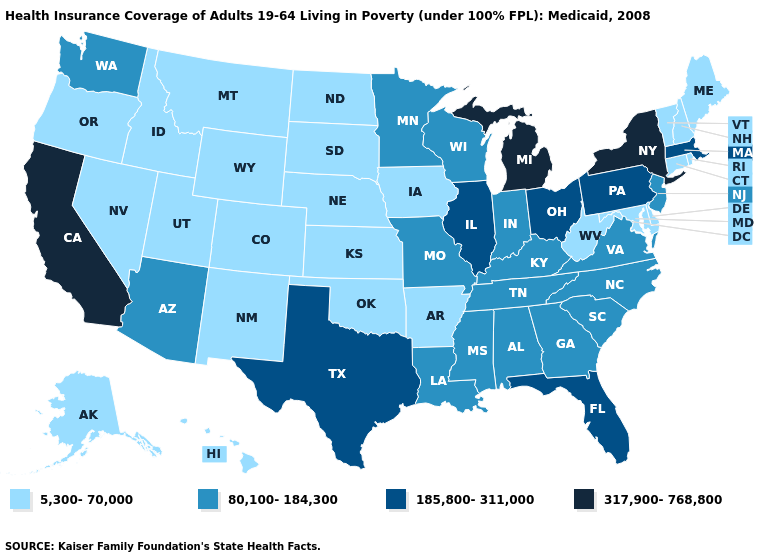Does the first symbol in the legend represent the smallest category?
Give a very brief answer. Yes. What is the highest value in the West ?
Be succinct. 317,900-768,800. What is the value of Kansas?
Quick response, please. 5,300-70,000. What is the highest value in the MidWest ?
Write a very short answer. 317,900-768,800. Among the states that border Connecticut , which have the lowest value?
Short answer required. Rhode Island. What is the value of Pennsylvania?
Short answer required. 185,800-311,000. Does Ohio have a higher value than Massachusetts?
Write a very short answer. No. What is the value of North Dakota?
Give a very brief answer. 5,300-70,000. Among the states that border Nevada , does Idaho have the lowest value?
Short answer required. Yes. Name the states that have a value in the range 185,800-311,000?
Be succinct. Florida, Illinois, Massachusetts, Ohio, Pennsylvania, Texas. Does the map have missing data?
Give a very brief answer. No. Does the map have missing data?
Give a very brief answer. No. Name the states that have a value in the range 185,800-311,000?
Be succinct. Florida, Illinois, Massachusetts, Ohio, Pennsylvania, Texas. Does the first symbol in the legend represent the smallest category?
Short answer required. Yes. Does the first symbol in the legend represent the smallest category?
Answer briefly. Yes. 